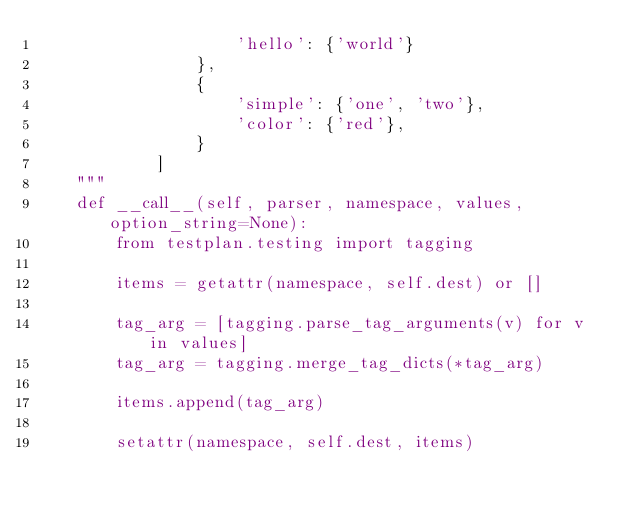<code> <loc_0><loc_0><loc_500><loc_500><_Python_>                    'hello': {'world'}
                },
                {
                    'simple': {'one', 'two'},
                    'color': {'red'},
                }
            ]
    """
    def __call__(self, parser, namespace, values, option_string=None):
        from testplan.testing import tagging

        items = getattr(namespace, self.dest) or []

        tag_arg = [tagging.parse_tag_arguments(v) for v in values]
        tag_arg = tagging.merge_tag_dicts(*tag_arg)

        items.append(tag_arg)

        setattr(namespace, self.dest, items)
</code> 